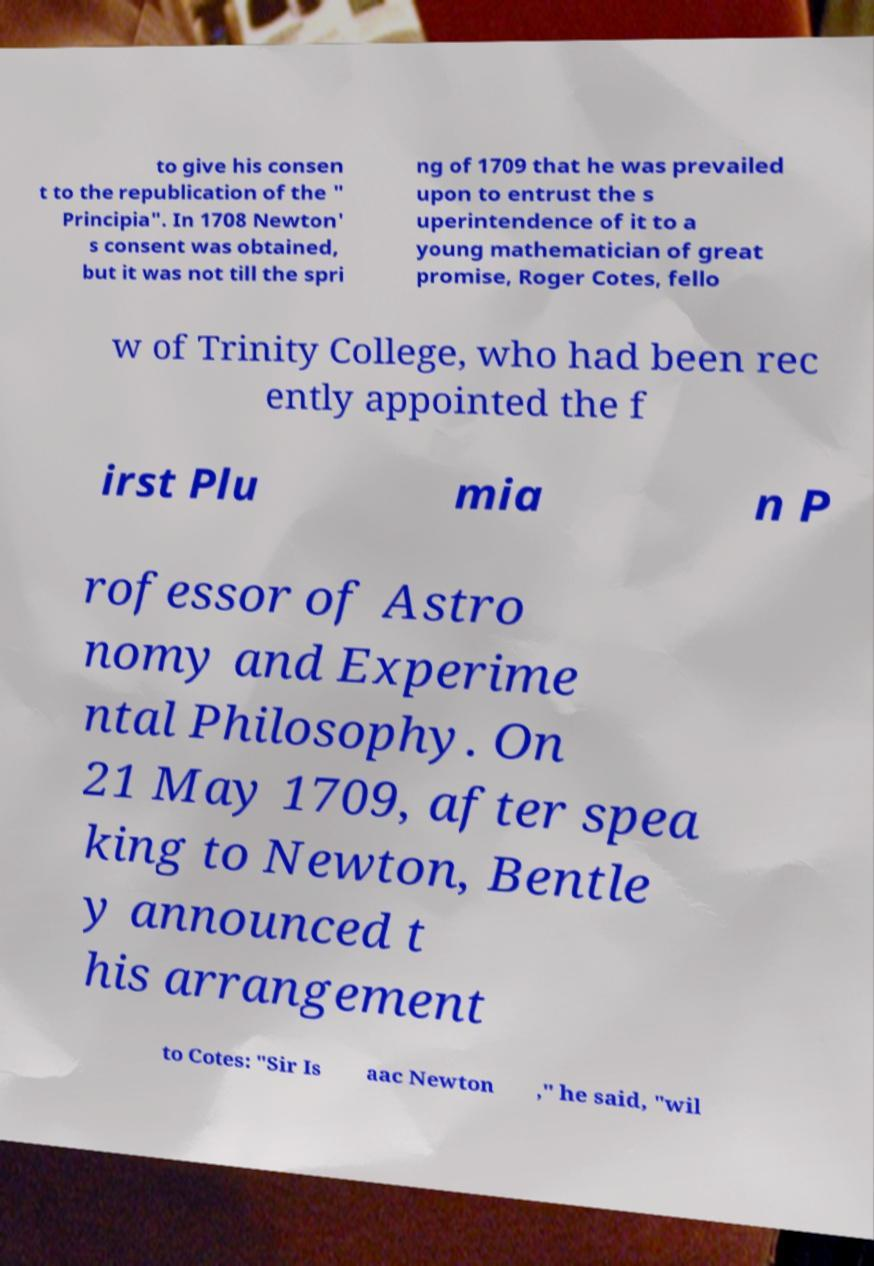I need the written content from this picture converted into text. Can you do that? to give his consen t to the republication of the " Principia". In 1708 Newton' s consent was obtained, but it was not till the spri ng of 1709 that he was prevailed upon to entrust the s uperintendence of it to a young mathematician of great promise, Roger Cotes, fello w of Trinity College, who had been rec ently appointed the f irst Plu mia n P rofessor of Astro nomy and Experime ntal Philosophy. On 21 May 1709, after spea king to Newton, Bentle y announced t his arrangement to Cotes: "Sir Is aac Newton ," he said, "wil 